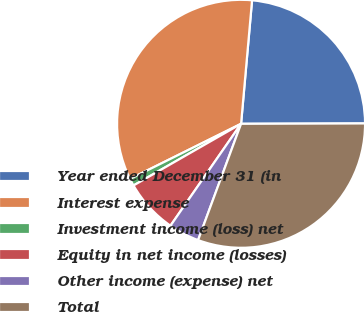<chart> <loc_0><loc_0><loc_500><loc_500><pie_chart><fcel>Year ended December 31 (in<fcel>Interest expense<fcel>Investment income (loss) net<fcel>Equity in net income (losses)<fcel>Other income (expense) net<fcel>Total<nl><fcel>23.54%<fcel>33.75%<fcel>0.95%<fcel>7.07%<fcel>4.01%<fcel>30.68%<nl></chart> 